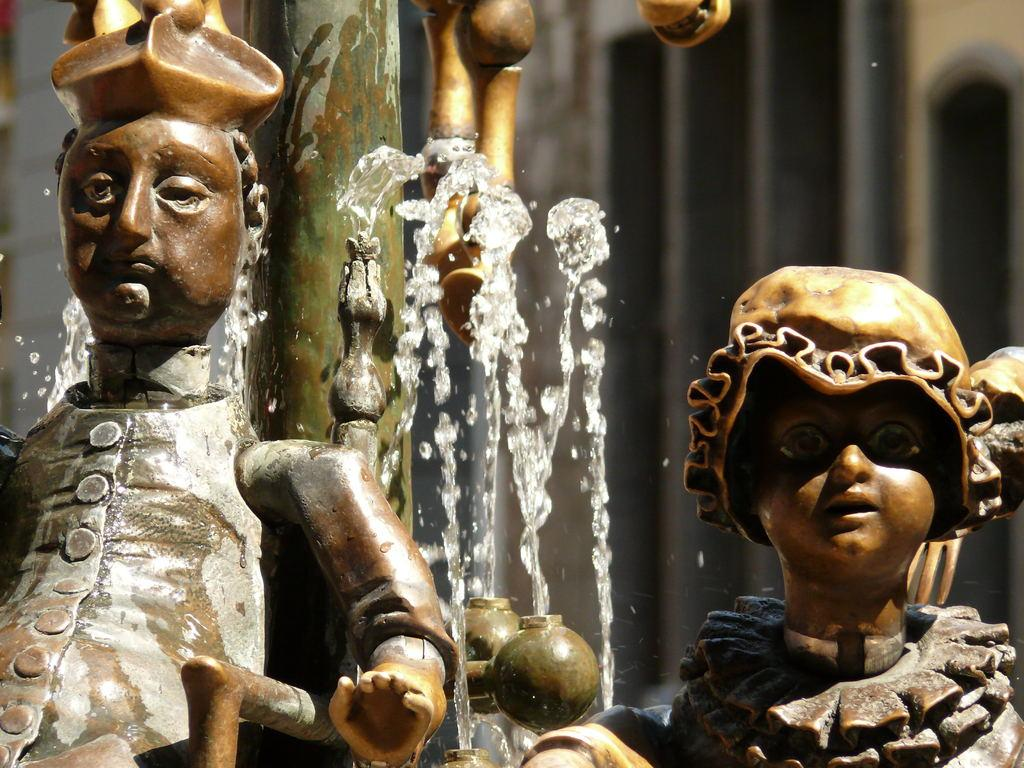What can be seen in the front of the image? There are two mini sculptures in the front of the image. What is visible in the background of the image? There is water visible in the background of the image. How many bees are flying around the mini sculptures in the image? There are no bees visible in the image; it only features the two mini sculptures and water in the background. 